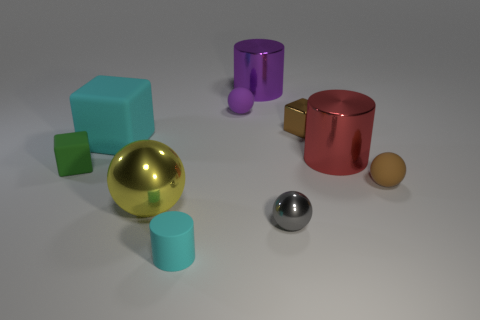Subtract all tiny gray balls. How many balls are left? 3 Subtract 2 spheres. How many spheres are left? 2 Subtract all yellow spheres. How many spheres are left? 3 Subtract all red balls. Subtract all green cubes. How many balls are left? 4 Subtract all blocks. How many objects are left? 7 Add 3 small rubber blocks. How many small rubber blocks exist? 4 Subtract 1 red cylinders. How many objects are left? 9 Subtract all big yellow shiny balls. Subtract all small cylinders. How many objects are left? 8 Add 8 green rubber things. How many green rubber things are left? 9 